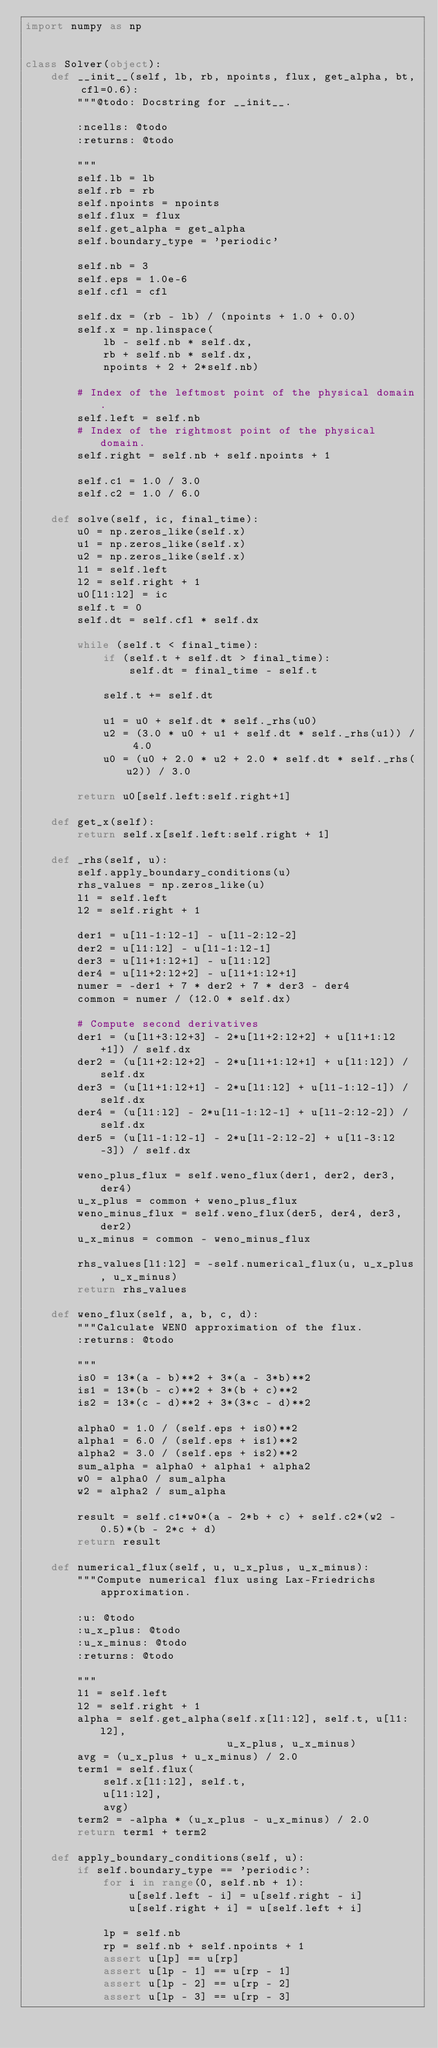<code> <loc_0><loc_0><loc_500><loc_500><_Python_>import numpy as np


class Solver(object):
    def __init__(self, lb, rb, npoints, flux, get_alpha, bt, cfl=0.6):
        """@todo: Docstring for __init__.

        :ncells: @todo
        :returns: @todo

        """
        self.lb = lb
        self.rb = rb
        self.npoints = npoints
        self.flux = flux
        self.get_alpha = get_alpha
        self.boundary_type = 'periodic'

        self.nb = 3
        self.eps = 1.0e-6
        self.cfl = cfl

        self.dx = (rb - lb) / (npoints + 1.0 + 0.0)
        self.x = np.linspace(
            lb - self.nb * self.dx,
            rb + self.nb * self.dx,
            npoints + 2 + 2*self.nb)

        # Index of the leftmost point of the physical domain.
        self.left = self.nb
        # Index of the rightmost point of the physical domain.
        self.right = self.nb + self.npoints + 1

        self.c1 = 1.0 / 3.0
        self.c2 = 1.0 / 6.0

    def solve(self, ic, final_time):
        u0 = np.zeros_like(self.x)
        u1 = np.zeros_like(self.x)
        u2 = np.zeros_like(self.x)
        l1 = self.left
        l2 = self.right + 1
        u0[l1:l2] = ic
        self.t = 0
        self.dt = self.cfl * self.dx

        while (self.t < final_time):
            if (self.t + self.dt > final_time):
                self.dt = final_time - self.t

            self.t += self.dt

            u1 = u0 + self.dt * self._rhs(u0)
            u2 = (3.0 * u0 + u1 + self.dt * self._rhs(u1)) / 4.0
            u0 = (u0 + 2.0 * u2 + 2.0 * self.dt * self._rhs(u2)) / 3.0

        return u0[self.left:self.right+1]

    def get_x(self):
        return self.x[self.left:self.right + 1]

    def _rhs(self, u):
        self.apply_boundary_conditions(u)
        rhs_values = np.zeros_like(u)
        l1 = self.left
        l2 = self.right + 1

        der1 = u[l1-1:l2-1] - u[l1-2:l2-2]
        der2 = u[l1:l2] - u[l1-1:l2-1]
        der3 = u[l1+1:l2+1] - u[l1:l2]
        der4 = u[l1+2:l2+2] - u[l1+1:l2+1]
        numer = -der1 + 7 * der2 + 7 * der3 - der4
        common = numer / (12.0 * self.dx)

        # Compute second derivatives
        der1 = (u[l1+3:l2+3] - 2*u[l1+2:l2+2] + u[l1+1:l2+1]) / self.dx
        der2 = (u[l1+2:l2+2] - 2*u[l1+1:l2+1] + u[l1:l2]) / self.dx
        der3 = (u[l1+1:l2+1] - 2*u[l1:l2] + u[l1-1:l2-1]) / self.dx
        der4 = (u[l1:l2] - 2*u[l1-1:l2-1] + u[l1-2:l2-2]) / self.dx
        der5 = (u[l1-1:l2-1] - 2*u[l1-2:l2-2] + u[l1-3:l2-3]) / self.dx

        weno_plus_flux = self.weno_flux(der1, der2, der3, der4)
        u_x_plus = common + weno_plus_flux
        weno_minus_flux = self.weno_flux(der5, der4, der3, der2)
        u_x_minus = common - weno_minus_flux

        rhs_values[l1:l2] = -self.numerical_flux(u, u_x_plus, u_x_minus)
        return rhs_values

    def weno_flux(self, a, b, c, d):
        """Calculate WENO approximation of the flux.
        :returns: @todo

        """
        is0 = 13*(a - b)**2 + 3*(a - 3*b)**2
        is1 = 13*(b - c)**2 + 3*(b + c)**2
        is2 = 13*(c - d)**2 + 3*(3*c - d)**2

        alpha0 = 1.0 / (self.eps + is0)**2
        alpha1 = 6.0 / (self.eps + is1)**2
        alpha2 = 3.0 / (self.eps + is2)**2
        sum_alpha = alpha0 + alpha1 + alpha2
        w0 = alpha0 / sum_alpha
        w2 = alpha2 / sum_alpha

        result = self.c1*w0*(a - 2*b + c) + self.c2*(w2 - 0.5)*(b - 2*c + d)
        return result

    def numerical_flux(self, u, u_x_plus, u_x_minus):
        """Compute numerical flux using Lax-Friedrichs approximation.

        :u: @todo
        :u_x_plus: @todo
        :u_x_minus: @todo
        :returns: @todo

        """
        l1 = self.left
        l2 = self.right + 1
        alpha = self.get_alpha(self.x[l1:l2], self.t, u[l1:l2],
                               u_x_plus, u_x_minus)
        avg = (u_x_plus + u_x_minus) / 2.0
        term1 = self.flux(
            self.x[l1:l2], self.t,
            u[l1:l2],
            avg)
        term2 = -alpha * (u_x_plus - u_x_minus) / 2.0
        return term1 + term2

    def apply_boundary_conditions(self, u):
        if self.boundary_type == 'periodic':
            for i in range(0, self.nb + 1):
                u[self.left - i] = u[self.right - i]
                u[self.right + i] = u[self.left + i]

            lp = self.nb
            rp = self.nb + self.npoints + 1
            assert u[lp] == u[rp]
            assert u[lp - 1] == u[rp - 1]
            assert u[lp - 2] == u[rp - 2]
            assert u[lp - 3] == u[rp - 3]</code> 